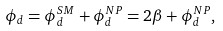Convert formula to latex. <formula><loc_0><loc_0><loc_500><loc_500>\phi _ { d } = \phi _ { d } ^ { S M } + \phi _ { d } ^ { N P } = 2 \beta + \phi _ { d } ^ { N P } ,</formula> 